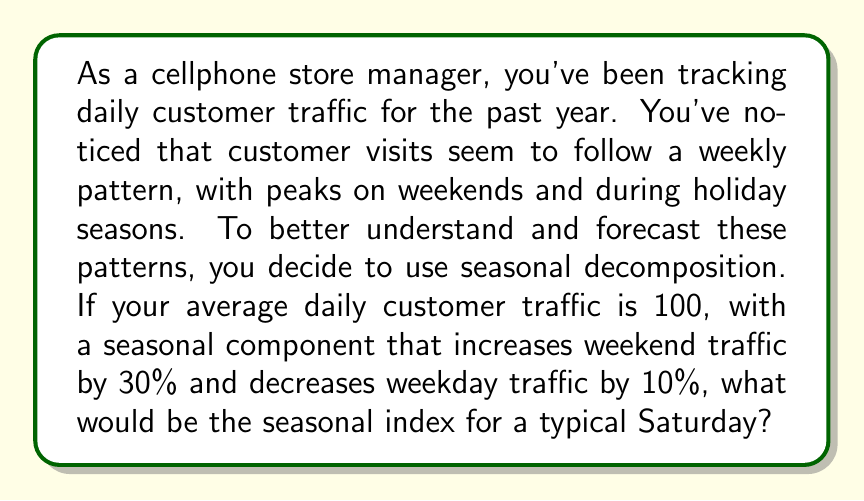Teach me how to tackle this problem. To solve this problem, we need to understand the concept of seasonal decomposition and how to calculate seasonal indices. Let's break it down step-by-step:

1) Seasonal decomposition separates a time series into three components:
   - Trend
   - Seasonal
   - Residual (or irregular)

2) The seasonal index represents the relative variation of each period compared to the overall average.

3) In this case, we have a weekly seasonality with two distinct patterns:
   - Weekends (Saturday and Sunday): Increased by 30%
   - Weekdays (Monday to Friday): Decreased by 10%

4) To calculate the seasonal indices, we need to ensure that they average to 1 over the full seasonal cycle (one week in this case).

5) Let's define our indices:
   Let $x$ be the weekend index and $y$ be the weekday index.

6) We know that:
   $x = 1.30$ (30% increase for weekends)
   $y = 0.90$ (10% decrease for weekdays)

7) To ensure the indices average to 1 over a week:

   $\frac{2x + 5y}{7} = 1$

8) Substituting the known values:

   $\frac{2(1.30) + 5(0.90)}{7} = 1$

9) Simplifying:

   $\frac{2.60 + 4.50}{7} = 1$

   $\frac{7.10}{7} = 1$

   $1.01428571 \approx 1$

The slight difference from 1 is due to rounding, but it's close enough for practical purposes.

Therefore, the seasonal index for a typical Saturday would be 1.30, or 130% of the average daily traffic.
Answer: The seasonal index for a typical Saturday is 1.30. 